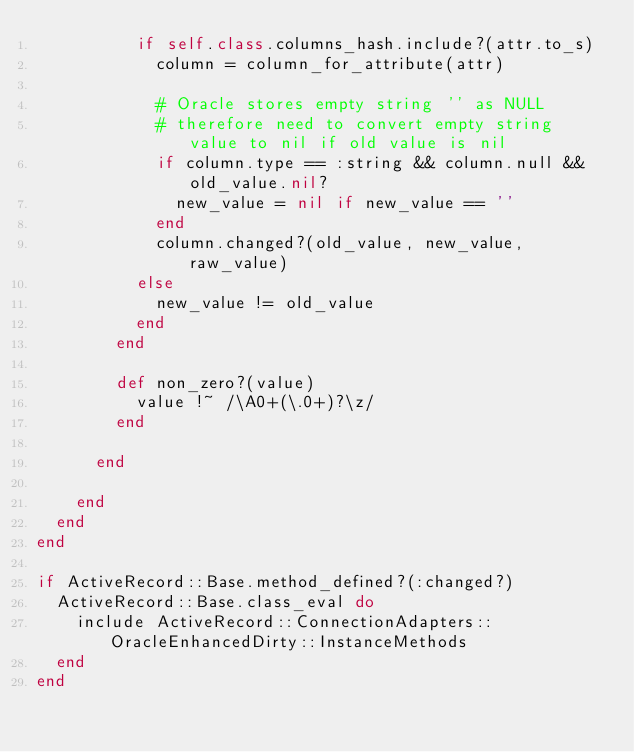<code> <loc_0><loc_0><loc_500><loc_500><_Ruby_>          if self.class.columns_hash.include?(attr.to_s)
            column = column_for_attribute(attr)

            # Oracle stores empty string '' as NULL
            # therefore need to convert empty string value to nil if old value is nil
            if column.type == :string && column.null && old_value.nil?
              new_value = nil if new_value == ''
            end
            column.changed?(old_value, new_value, raw_value)
          else
            new_value != old_value
          end
        end

        def non_zero?(value)
          value !~ /\A0+(\.0+)?\z/
        end 
        
      end

    end
  end
end

if ActiveRecord::Base.method_defined?(:changed?)
  ActiveRecord::Base.class_eval do
    include ActiveRecord::ConnectionAdapters::OracleEnhancedDirty::InstanceMethods
  end
end
</code> 